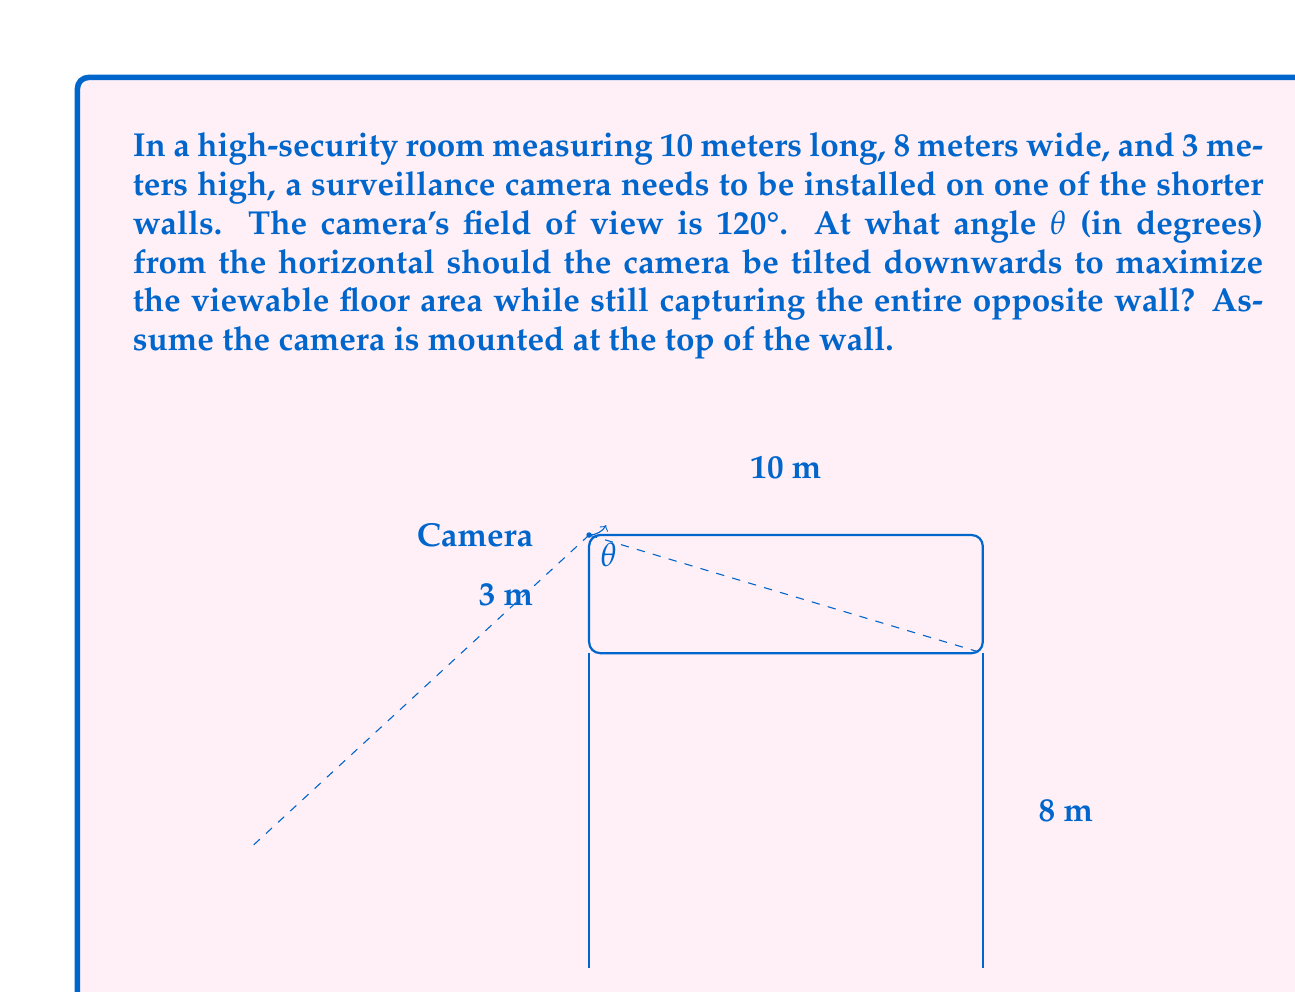Can you answer this question? To solve this problem, we need to follow these steps:

1) First, we need to understand that the optimal angle will be achieved when the camera's field of view just touches the far bottom corner of the room.

2) We can split the problem into two right triangles: one vertical and one horizontal.

3) For the vertical triangle:
   - The adjacent side is the room length (10 m)
   - The opposite side is the room height (3 m)
   - We need to find the angle from horizontal to the line connecting the camera to the far bottom edge

   $$\tan(\alpha) = \frac{\text{opposite}}{\text{adjacent}} = \frac{3}{10}$$
   $$\alpha = \tan^{-1}(\frac{3}{10}) \approx 16.70°$$

4) For the horizontal triangle:
   - The field of view is 120°, so each half of it is 60°
   - We need to find the angle from the center line to the corner

   $$\tan(60°) = \frac{\text{half width}}{\text{length}} = \frac{4}{10}$$

5) The optimal tilt angle θ will be the difference between these two angles:

   $$\theta = 60° - \alpha$$
   $$\theta = 60° - 16.70° = 43.30°$$

6) Rounding to two decimal places, we get 43.30°.
Answer: The optimal angle θ for the camera tilt is approximately 43.30°. 